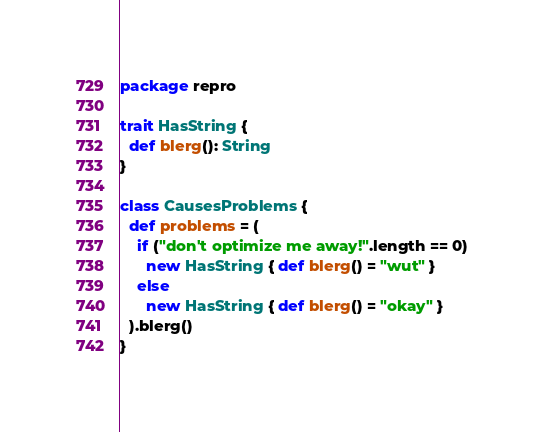<code> <loc_0><loc_0><loc_500><loc_500><_Scala_>package repro

trait HasString {
  def blerg(): String
}

class CausesProblems {
  def problems = (
    if ("don't optimize me away!".length == 0)
      new HasString { def blerg() = "wut" }
    else
      new HasString { def blerg() = "okay" }
  ).blerg()
}
</code> 